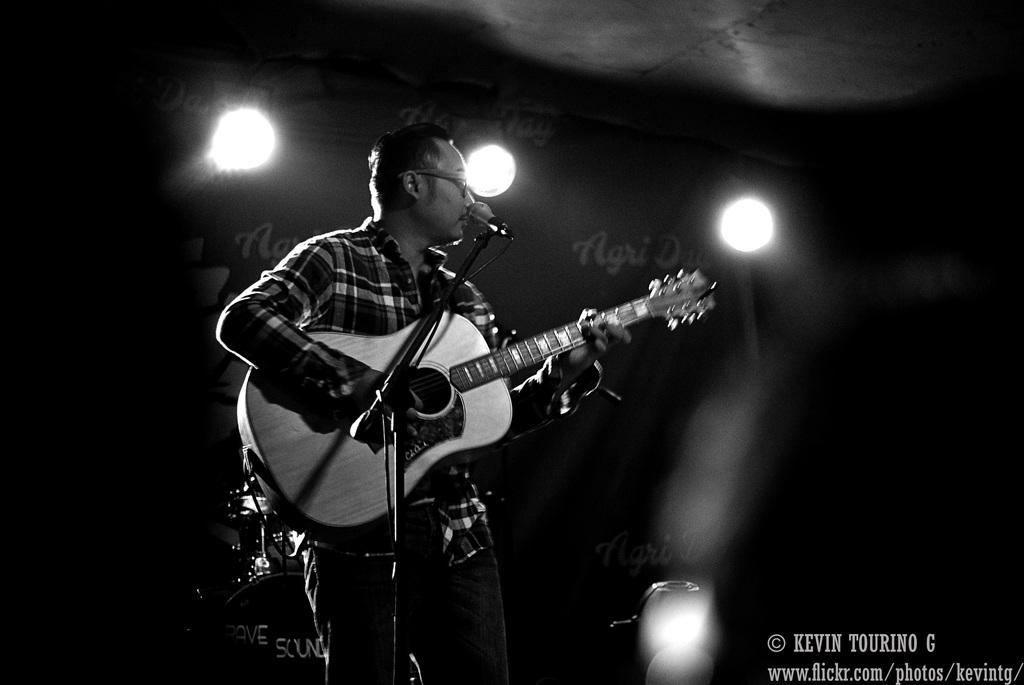What is the person in the image doing? The person is standing and playing a guitar. What accessory is the person wearing? The person is wearing a spectacle. What can be seen in the background of the image? There is a banner and lights in the background. What type of road can be seen in the background of the image? There is no road visible in the background of the image; it features a banner and lights. Can you describe the mountain range in the image? There is no mountain range present in the image. 